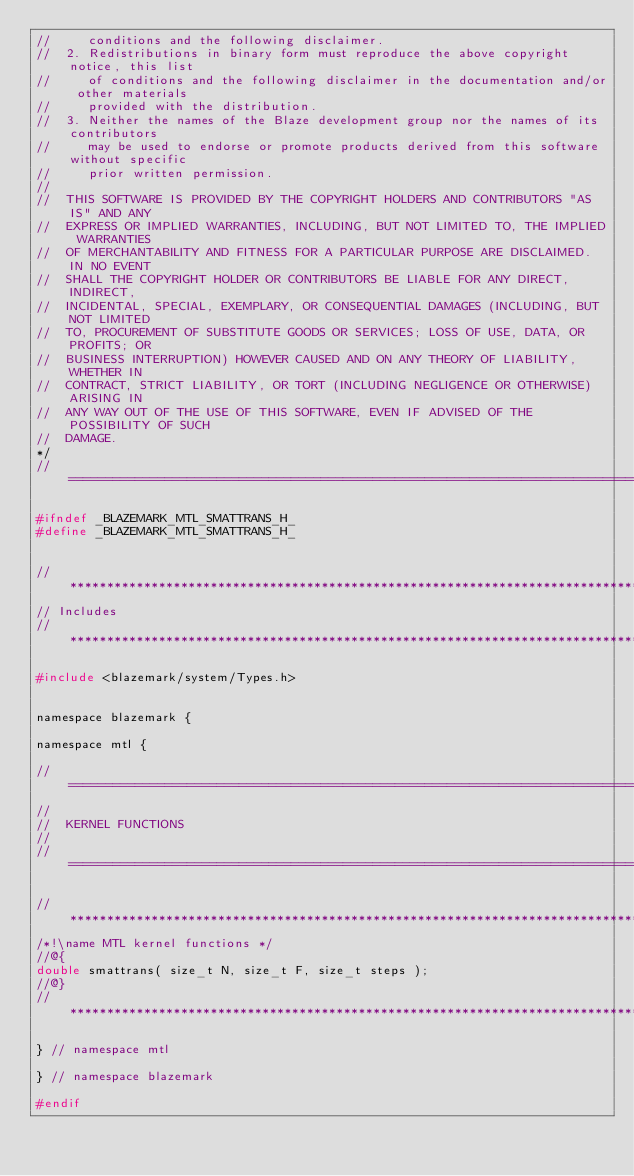<code> <loc_0><loc_0><loc_500><loc_500><_C_>//     conditions and the following disclaimer.
//  2. Redistributions in binary form must reproduce the above copyright notice, this list
//     of conditions and the following disclaimer in the documentation and/or other materials
//     provided with the distribution.
//  3. Neither the names of the Blaze development group nor the names of its contributors
//     may be used to endorse or promote products derived from this software without specific
//     prior written permission.
//
//  THIS SOFTWARE IS PROVIDED BY THE COPYRIGHT HOLDERS AND CONTRIBUTORS "AS IS" AND ANY
//  EXPRESS OR IMPLIED WARRANTIES, INCLUDING, BUT NOT LIMITED TO, THE IMPLIED WARRANTIES
//  OF MERCHANTABILITY AND FITNESS FOR A PARTICULAR PURPOSE ARE DISCLAIMED. IN NO EVENT
//  SHALL THE COPYRIGHT HOLDER OR CONTRIBUTORS BE LIABLE FOR ANY DIRECT, INDIRECT,
//  INCIDENTAL, SPECIAL, EXEMPLARY, OR CONSEQUENTIAL DAMAGES (INCLUDING, BUT NOT LIMITED
//  TO, PROCUREMENT OF SUBSTITUTE GOODS OR SERVICES; LOSS OF USE, DATA, OR PROFITS; OR
//  BUSINESS INTERRUPTION) HOWEVER CAUSED AND ON ANY THEORY OF LIABILITY, WHETHER IN
//  CONTRACT, STRICT LIABILITY, OR TORT (INCLUDING NEGLIGENCE OR OTHERWISE) ARISING IN
//  ANY WAY OUT OF THE USE OF THIS SOFTWARE, EVEN IF ADVISED OF THE POSSIBILITY OF SUCH
//  DAMAGE.
*/
//=================================================================================================

#ifndef _BLAZEMARK_MTL_SMATTRANS_H_
#define _BLAZEMARK_MTL_SMATTRANS_H_


//*************************************************************************************************
// Includes
//*************************************************************************************************

#include <blazemark/system/Types.h>


namespace blazemark {

namespace mtl {

//=================================================================================================
//
//  KERNEL FUNCTIONS
//
//=================================================================================================

//*************************************************************************************************
/*!\name MTL kernel functions */
//@{
double smattrans( size_t N, size_t F, size_t steps );
//@}
//*************************************************************************************************

} // namespace mtl

} // namespace blazemark

#endif
</code> 